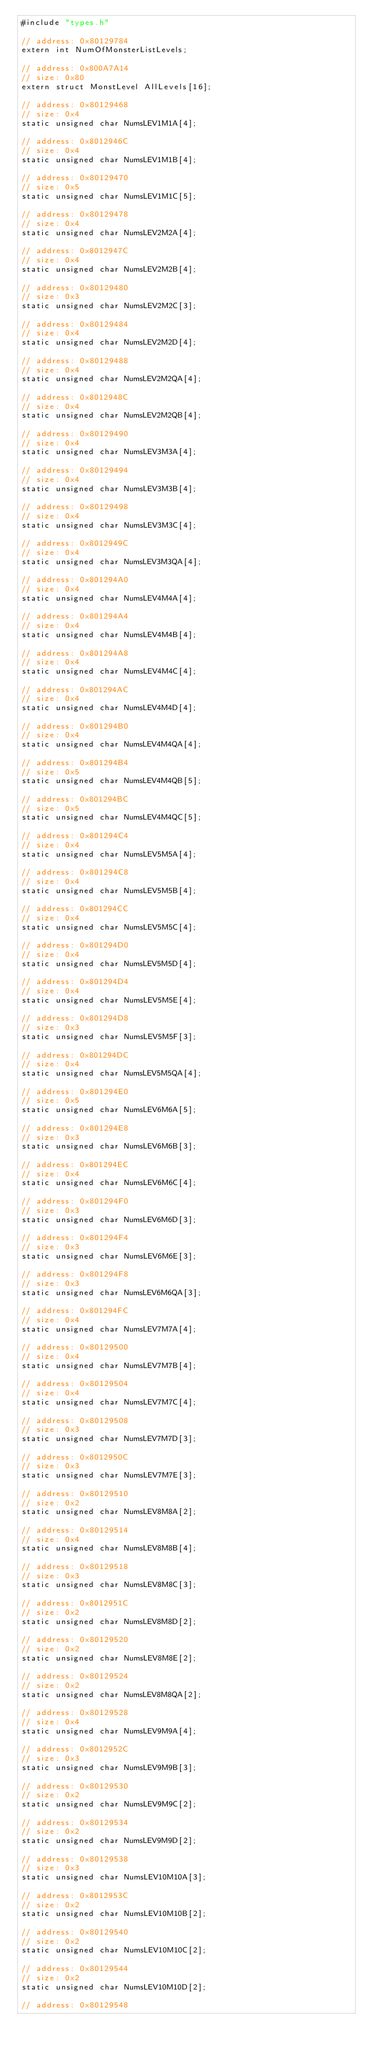<code> <loc_0><loc_0><loc_500><loc_500><_C_>#include "types.h"

// address: 0x80129784
extern int NumOfMonsterListLevels;

// address: 0x800A7A14
// size: 0x80
extern struct MonstLevel AllLevels[16];

// address: 0x80129468
// size: 0x4
static unsigned char NumsLEV1M1A[4];

// address: 0x8012946C
// size: 0x4
static unsigned char NumsLEV1M1B[4];

// address: 0x80129470
// size: 0x5
static unsigned char NumsLEV1M1C[5];

// address: 0x80129478
// size: 0x4
static unsigned char NumsLEV2M2A[4];

// address: 0x8012947C
// size: 0x4
static unsigned char NumsLEV2M2B[4];

// address: 0x80129480
// size: 0x3
static unsigned char NumsLEV2M2C[3];

// address: 0x80129484
// size: 0x4
static unsigned char NumsLEV2M2D[4];

// address: 0x80129488
// size: 0x4
static unsigned char NumsLEV2M2QA[4];

// address: 0x8012948C
// size: 0x4
static unsigned char NumsLEV2M2QB[4];

// address: 0x80129490
// size: 0x4
static unsigned char NumsLEV3M3A[4];

// address: 0x80129494
// size: 0x4
static unsigned char NumsLEV3M3B[4];

// address: 0x80129498
// size: 0x4
static unsigned char NumsLEV3M3C[4];

// address: 0x8012949C
// size: 0x4
static unsigned char NumsLEV3M3QA[4];

// address: 0x801294A0
// size: 0x4
static unsigned char NumsLEV4M4A[4];

// address: 0x801294A4
// size: 0x4
static unsigned char NumsLEV4M4B[4];

// address: 0x801294A8
// size: 0x4
static unsigned char NumsLEV4M4C[4];

// address: 0x801294AC
// size: 0x4
static unsigned char NumsLEV4M4D[4];

// address: 0x801294B0
// size: 0x4
static unsigned char NumsLEV4M4QA[4];

// address: 0x801294B4
// size: 0x5
static unsigned char NumsLEV4M4QB[5];

// address: 0x801294BC
// size: 0x5
static unsigned char NumsLEV4M4QC[5];

// address: 0x801294C4
// size: 0x4
static unsigned char NumsLEV5M5A[4];

// address: 0x801294C8
// size: 0x4
static unsigned char NumsLEV5M5B[4];

// address: 0x801294CC
// size: 0x4
static unsigned char NumsLEV5M5C[4];

// address: 0x801294D0
// size: 0x4
static unsigned char NumsLEV5M5D[4];

// address: 0x801294D4
// size: 0x4
static unsigned char NumsLEV5M5E[4];

// address: 0x801294D8
// size: 0x3
static unsigned char NumsLEV5M5F[3];

// address: 0x801294DC
// size: 0x4
static unsigned char NumsLEV5M5QA[4];

// address: 0x801294E0
// size: 0x5
static unsigned char NumsLEV6M6A[5];

// address: 0x801294E8
// size: 0x3
static unsigned char NumsLEV6M6B[3];

// address: 0x801294EC
// size: 0x4
static unsigned char NumsLEV6M6C[4];

// address: 0x801294F0
// size: 0x3
static unsigned char NumsLEV6M6D[3];

// address: 0x801294F4
// size: 0x3
static unsigned char NumsLEV6M6E[3];

// address: 0x801294F8
// size: 0x3
static unsigned char NumsLEV6M6QA[3];

// address: 0x801294FC
// size: 0x4
static unsigned char NumsLEV7M7A[4];

// address: 0x80129500
// size: 0x4
static unsigned char NumsLEV7M7B[4];

// address: 0x80129504
// size: 0x4
static unsigned char NumsLEV7M7C[4];

// address: 0x80129508
// size: 0x3
static unsigned char NumsLEV7M7D[3];

// address: 0x8012950C
// size: 0x3
static unsigned char NumsLEV7M7E[3];

// address: 0x80129510
// size: 0x2
static unsigned char NumsLEV8M8A[2];

// address: 0x80129514
// size: 0x4
static unsigned char NumsLEV8M8B[4];

// address: 0x80129518
// size: 0x3
static unsigned char NumsLEV8M8C[3];

// address: 0x8012951C
// size: 0x2
static unsigned char NumsLEV8M8D[2];

// address: 0x80129520
// size: 0x2
static unsigned char NumsLEV8M8E[2];

// address: 0x80129524
// size: 0x2
static unsigned char NumsLEV8M8QA[2];

// address: 0x80129528
// size: 0x4
static unsigned char NumsLEV9M9A[4];

// address: 0x8012952C
// size: 0x3
static unsigned char NumsLEV9M9B[3];

// address: 0x80129530
// size: 0x2
static unsigned char NumsLEV9M9C[2];

// address: 0x80129534
// size: 0x2
static unsigned char NumsLEV9M9D[2];

// address: 0x80129538
// size: 0x3
static unsigned char NumsLEV10M10A[3];

// address: 0x8012953C
// size: 0x2
static unsigned char NumsLEV10M10B[2];

// address: 0x80129540
// size: 0x2
static unsigned char NumsLEV10M10C[2];

// address: 0x80129544
// size: 0x2
static unsigned char NumsLEV10M10D[2];

// address: 0x80129548</code> 